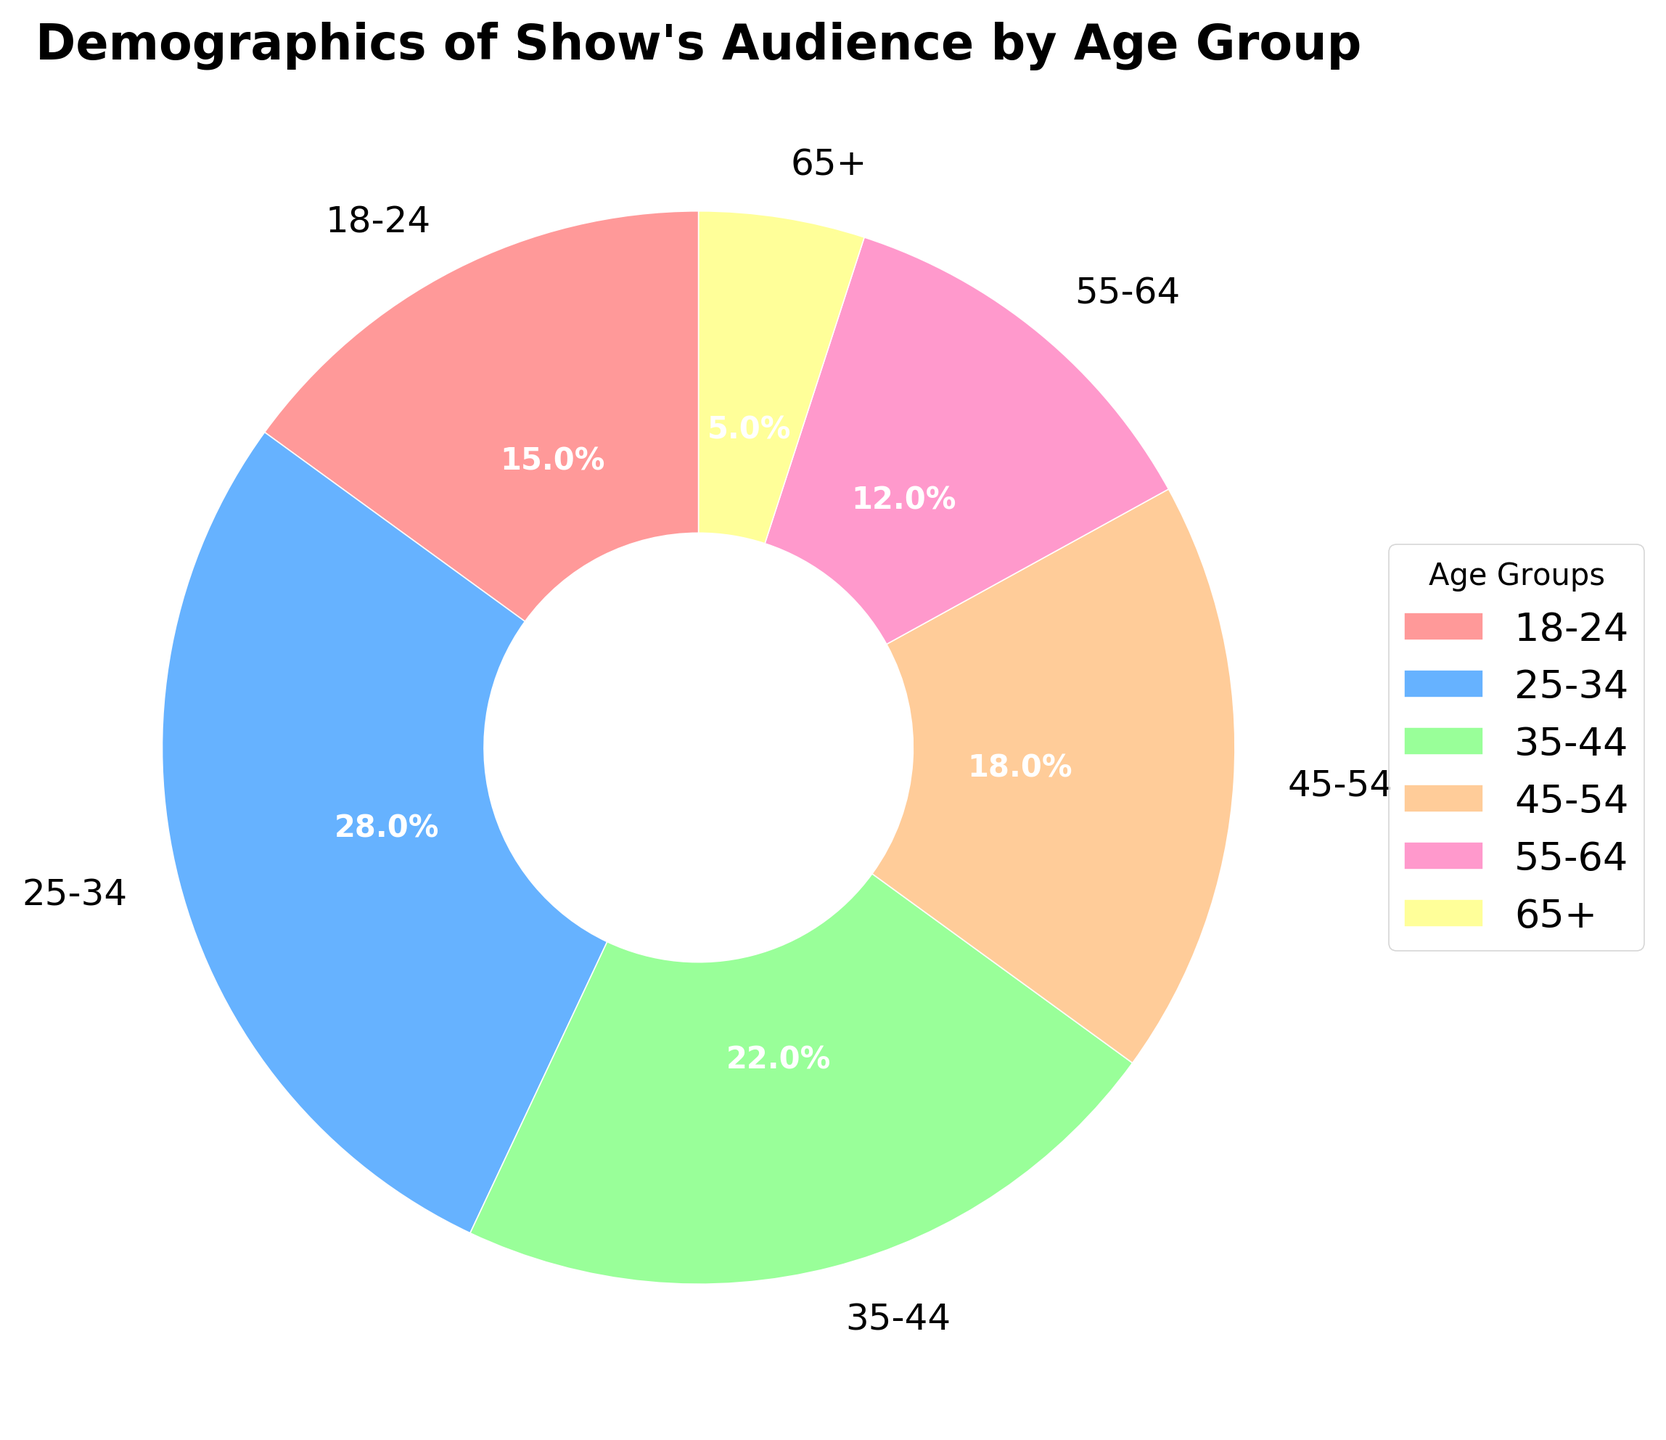Which age group has the largest audience percentage? From the pie chart, locate the largest segment and its associated label. The 25-34 age group has the largest percentage.
Answer: 25-34 What is the combined percentage of the 35-44 and 45-54 age groups? Add the percentages of the 35-44 and 45-54 age groups: 22% + 18% = 40%.
Answer: 40% Is the proportion of the 18-24 age group larger or smaller than the 55-64 age group? Compare the percentages of the 18-24 and 55-64 age groups: 15% for 18-24 and 12% for 55-64, so 18-24 is larger.
Answer: Larger What's the difference between the percentage of the largest and the smallest age group? Subtract the percentage of the smallest age group (65+: 5%) from the largest (25-34: 28%): 28% - 5% = 23%.
Answer: 23% What percentage of the audience is below 35 years old? Sum the percentages of age groups 18-24 and 25-34: 15% + 28% = 43%.
Answer: 43% Which age group is represented by a pink segment? Identify the pink segment in the pie chart and match it with its label. The 18-24 age group is represented by pink.
Answer: 18-24 Is the percentage of the 45-54 age group more than double that of the 65+ age group? Compare if 18% (45-54) is more than double 5% (65+): Double 5% is 10%, and 18% is more than 10%.
Answer: Yes Combine the percentages of the 55-64 and 65+ age groups. What fraction of the total audience do they represent? Add the percentages of 55-64 (12%) and 65+ (5%) to get 17%, which represents 17/100 or simplified to 17/100 of the total audience.
Answer: 17/100 Which age group has the smallest percentage, and what color represents it? Identify the segment with the smallest size in the pie chart, which is labeled 65+, and note its color represented as yellow.
Answer: 65+, yellow 